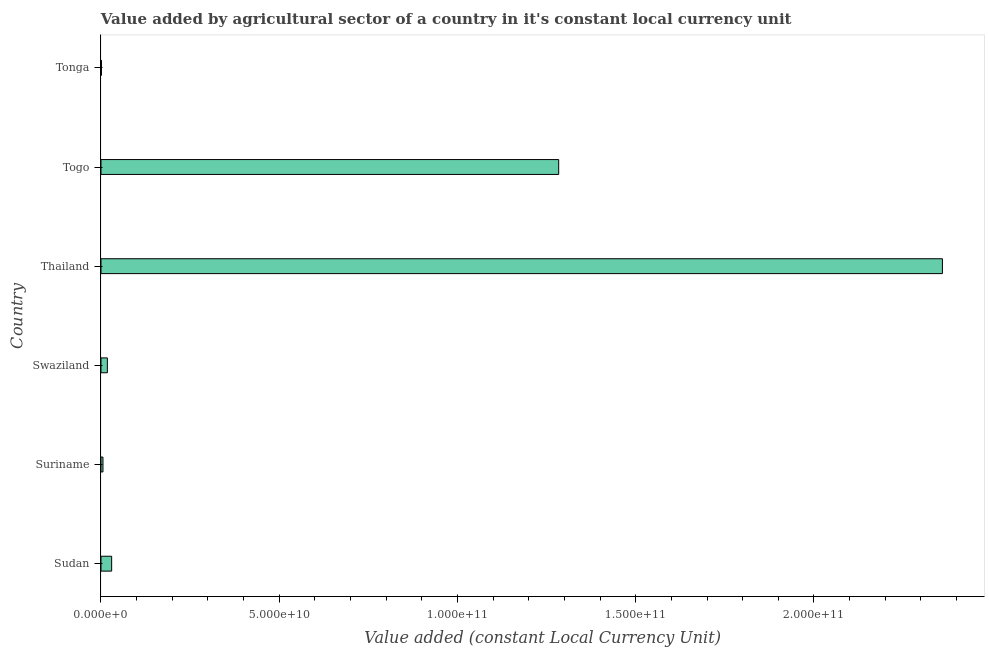Does the graph contain any zero values?
Make the answer very short. No. What is the title of the graph?
Offer a very short reply. Value added by agricultural sector of a country in it's constant local currency unit. What is the label or title of the X-axis?
Give a very brief answer. Value added (constant Local Currency Unit). What is the label or title of the Y-axis?
Your answer should be very brief. Country. What is the value added by agriculture sector in Swaziland?
Provide a succinct answer. 1.79e+09. Across all countries, what is the maximum value added by agriculture sector?
Provide a short and direct response. 2.36e+11. Across all countries, what is the minimum value added by agriculture sector?
Give a very brief answer. 1.29e+08. In which country was the value added by agriculture sector maximum?
Offer a terse response. Thailand. In which country was the value added by agriculture sector minimum?
Your answer should be compact. Tonga. What is the sum of the value added by agriculture sector?
Provide a succinct answer. 3.70e+11. What is the difference between the value added by agriculture sector in Suriname and Thailand?
Provide a short and direct response. -2.35e+11. What is the average value added by agriculture sector per country?
Give a very brief answer. 6.16e+1. What is the median value added by agriculture sector?
Keep it short and to the point. 2.39e+09. What is the ratio of the value added by agriculture sector in Sudan to that in Togo?
Give a very brief answer. 0.02. What is the difference between the highest and the second highest value added by agriculture sector?
Offer a very short reply. 1.08e+11. Is the sum of the value added by agriculture sector in Togo and Tonga greater than the maximum value added by agriculture sector across all countries?
Provide a succinct answer. No. What is the difference between the highest and the lowest value added by agriculture sector?
Your answer should be very brief. 2.36e+11. In how many countries, is the value added by agriculture sector greater than the average value added by agriculture sector taken over all countries?
Ensure brevity in your answer.  2. How many bars are there?
Your answer should be compact. 6. Are all the bars in the graph horizontal?
Offer a very short reply. Yes. What is the difference between two consecutive major ticks on the X-axis?
Make the answer very short. 5.00e+1. What is the Value added (constant Local Currency Unit) in Sudan?
Offer a very short reply. 2.99e+09. What is the Value added (constant Local Currency Unit) of Suriname?
Your response must be concise. 5.55e+08. What is the Value added (constant Local Currency Unit) in Swaziland?
Provide a succinct answer. 1.79e+09. What is the Value added (constant Local Currency Unit) of Thailand?
Your answer should be compact. 2.36e+11. What is the Value added (constant Local Currency Unit) of Togo?
Your response must be concise. 1.28e+11. What is the Value added (constant Local Currency Unit) of Tonga?
Your answer should be compact. 1.29e+08. What is the difference between the Value added (constant Local Currency Unit) in Sudan and Suriname?
Give a very brief answer. 2.44e+09. What is the difference between the Value added (constant Local Currency Unit) in Sudan and Swaziland?
Offer a very short reply. 1.20e+09. What is the difference between the Value added (constant Local Currency Unit) in Sudan and Thailand?
Provide a succinct answer. -2.33e+11. What is the difference between the Value added (constant Local Currency Unit) in Sudan and Togo?
Your answer should be very brief. -1.25e+11. What is the difference between the Value added (constant Local Currency Unit) in Sudan and Tonga?
Your answer should be compact. 2.86e+09. What is the difference between the Value added (constant Local Currency Unit) in Suriname and Swaziland?
Provide a succinct answer. -1.23e+09. What is the difference between the Value added (constant Local Currency Unit) in Suriname and Thailand?
Offer a terse response. -2.35e+11. What is the difference between the Value added (constant Local Currency Unit) in Suriname and Togo?
Ensure brevity in your answer.  -1.28e+11. What is the difference between the Value added (constant Local Currency Unit) in Suriname and Tonga?
Your response must be concise. 4.26e+08. What is the difference between the Value added (constant Local Currency Unit) in Swaziland and Thailand?
Make the answer very short. -2.34e+11. What is the difference between the Value added (constant Local Currency Unit) in Swaziland and Togo?
Offer a very short reply. -1.27e+11. What is the difference between the Value added (constant Local Currency Unit) in Swaziland and Tonga?
Offer a very short reply. 1.66e+09. What is the difference between the Value added (constant Local Currency Unit) in Thailand and Togo?
Offer a very short reply. 1.08e+11. What is the difference between the Value added (constant Local Currency Unit) in Thailand and Tonga?
Your answer should be very brief. 2.36e+11. What is the difference between the Value added (constant Local Currency Unit) in Togo and Tonga?
Provide a succinct answer. 1.28e+11. What is the ratio of the Value added (constant Local Currency Unit) in Sudan to that in Suriname?
Provide a succinct answer. 5.39. What is the ratio of the Value added (constant Local Currency Unit) in Sudan to that in Swaziland?
Your answer should be compact. 1.67. What is the ratio of the Value added (constant Local Currency Unit) in Sudan to that in Thailand?
Ensure brevity in your answer.  0.01. What is the ratio of the Value added (constant Local Currency Unit) in Sudan to that in Togo?
Your response must be concise. 0.02. What is the ratio of the Value added (constant Local Currency Unit) in Sudan to that in Tonga?
Your answer should be very brief. 23.24. What is the ratio of the Value added (constant Local Currency Unit) in Suriname to that in Swaziland?
Ensure brevity in your answer.  0.31. What is the ratio of the Value added (constant Local Currency Unit) in Suriname to that in Thailand?
Offer a very short reply. 0. What is the ratio of the Value added (constant Local Currency Unit) in Suriname to that in Togo?
Your answer should be compact. 0. What is the ratio of the Value added (constant Local Currency Unit) in Suriname to that in Tonga?
Make the answer very short. 4.31. What is the ratio of the Value added (constant Local Currency Unit) in Swaziland to that in Thailand?
Your response must be concise. 0.01. What is the ratio of the Value added (constant Local Currency Unit) in Swaziland to that in Togo?
Make the answer very short. 0.01. What is the ratio of the Value added (constant Local Currency Unit) in Swaziland to that in Tonga?
Offer a very short reply. 13.89. What is the ratio of the Value added (constant Local Currency Unit) in Thailand to that in Togo?
Give a very brief answer. 1.84. What is the ratio of the Value added (constant Local Currency Unit) in Thailand to that in Tonga?
Your response must be concise. 1833.45. What is the ratio of the Value added (constant Local Currency Unit) in Togo to that in Tonga?
Your answer should be compact. 997.31. 